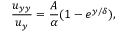Convert formula to latex. <formula><loc_0><loc_0><loc_500><loc_500>\frac { u _ { y y } } { u _ { y } } = \frac { A } { \alpha } ( 1 - e ^ { { y } / { \delta } } ) ,</formula> 